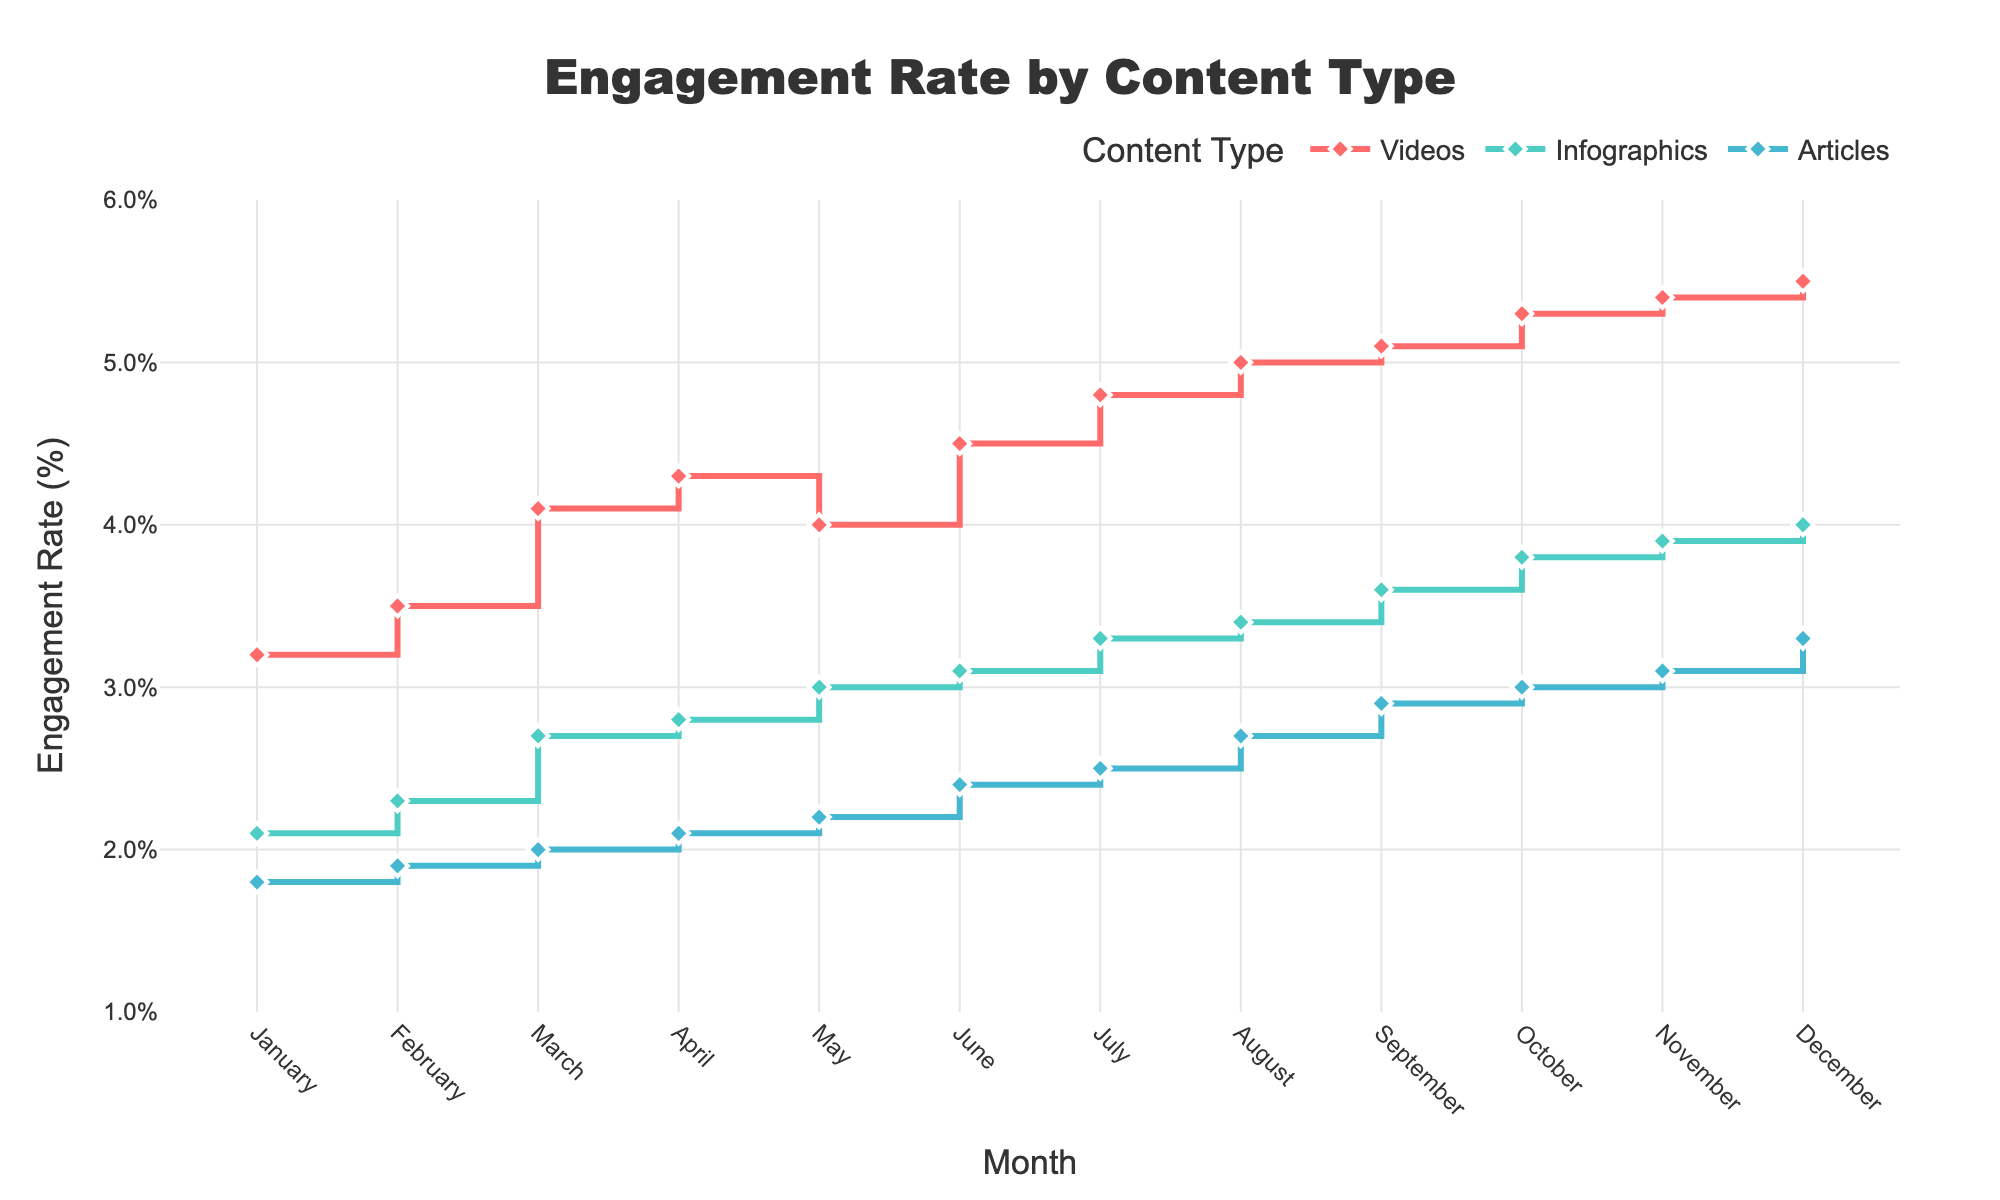What is the title of the figure? The title is centrally placed at the top of the plot and provides a summary of what the visual data represents.
Answer: Engagement Rate by Content Type Which content type showed the highest engagement rate overall? By examining the three lines, the line for Videos consistently reaches higher values compared to Infographics and Articles throughout the months.
Answer: Videos How did the engagement rate for Videos change from January to December? To determine this, look at the starting point in January (3.2%) and the ending point in December (5.5%) for the Videos line.
Answer: Increased by 2.3% During which month did Infographics first surpass a 3.0% engagement rate? Follow the line for Infographics and check when it first reaches or exceeds 3.0%; this occurs in May.
Answer: May Compare the engagement rate trends of Articles and Infographics. Which one had a more consistent increase throughout the year? Both lines show an upward trend, but Infographics increases more steadily without any significant dips, unlike Articles which show minor fluctuations.
Answer: Infographics What is the total increase in engagement rate for Articles from January to December? Calculate the difference between the data point in January (1.8%) and December (3.3%).
Answer: 1.5% In which month did Articles reach its highest engagement rate? By examining the peak of the line corresponding to Articles, the highest point occurs in December at 3.3%.
Answer: December How many months did the engagement rate for Videos stay above 4.0%? Count the data points for Videos above the 4.0% line; these are from April to December, totaling 9 months.
Answer: 9 months Did the engagement rates for any content type ever decrease during the year? Analyze each content type's line for any downward trend; the lines for Videos, Infographics, and Articles steadily increase without any decrease.
Answer: No Which month observed the highest collective engagement rate when adding all three content types? By summing up the engagement rates for each content type per month, December has the highest total (5.5% + 4.0% + 3.3% = 12.8%).
Answer: December 